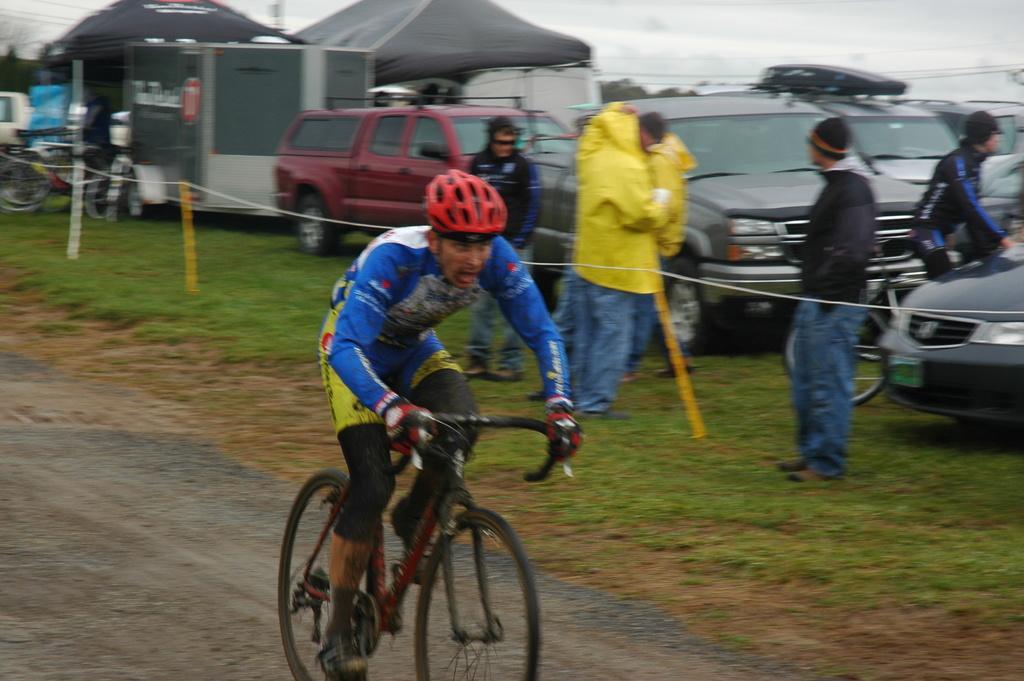Describe this image in one or two sentences. In the middle of the image a person is riding a bicycle. Behind him there is fencing. Behind the fencing few people are standing and few people are holding some bicycles. Behind them there are some vehicles and tents and trees. At the top of the image there is sky. 